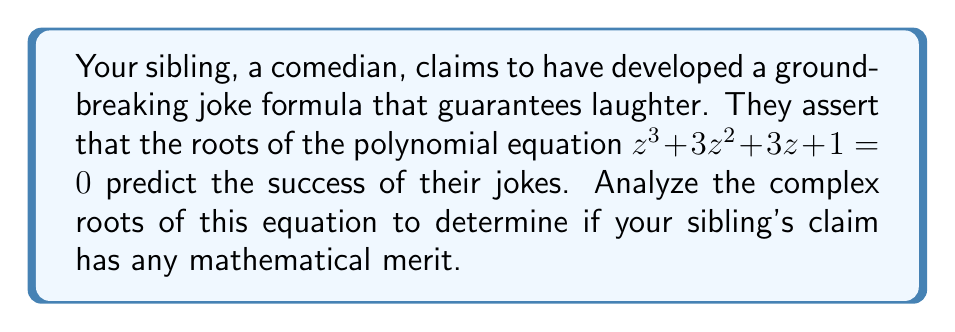Can you answer this question? Let's approach this step-by-step:

1) First, we need to find the roots of the equation $z^3 + 3z^2 + 3z + 1 = 0$.

2) This polynomial can be factored as $(z + 1)^3 = 0$.

3) Solving $(z + 1)^3 = 0$, we get:
   $z + 1 = 0$
   $z = -1$

4) This means that the equation has a single root, $z = -1$, with multiplicity 3.

5) In the complex plane, this root is located at the point $(-1, 0)$.

6) The fact that there is only one real root, repeated three times, indicates that:
   a) There is no variation in the roots.
   b) The root is not complex, but a simple real number.
   c) The root is negative, which in many contexts represents a decline or decrease.

7) From a mathematical perspective, this lack of diversity in roots suggests a lack of complexity or variability in the system it represents.

8) Interpreting this in the context of your sibling's claim:
   - The single, repeated root suggests a lack of variety or unpredictability in their joke formula.
   - The negative value of the root might imply a tendency towards declining success or audience dissatisfaction.

9) Therefore, the analysis of the complex roots does not support your sibling's claim of a groundbreaking or successful joke formula. Instead, it mathematically suggests predictability and potential decline, aligning with your skeptical view of their comedy.
Answer: The equation has a single root $z = -1$ with multiplicity 3, suggesting predictability and potential decline rather than success. 